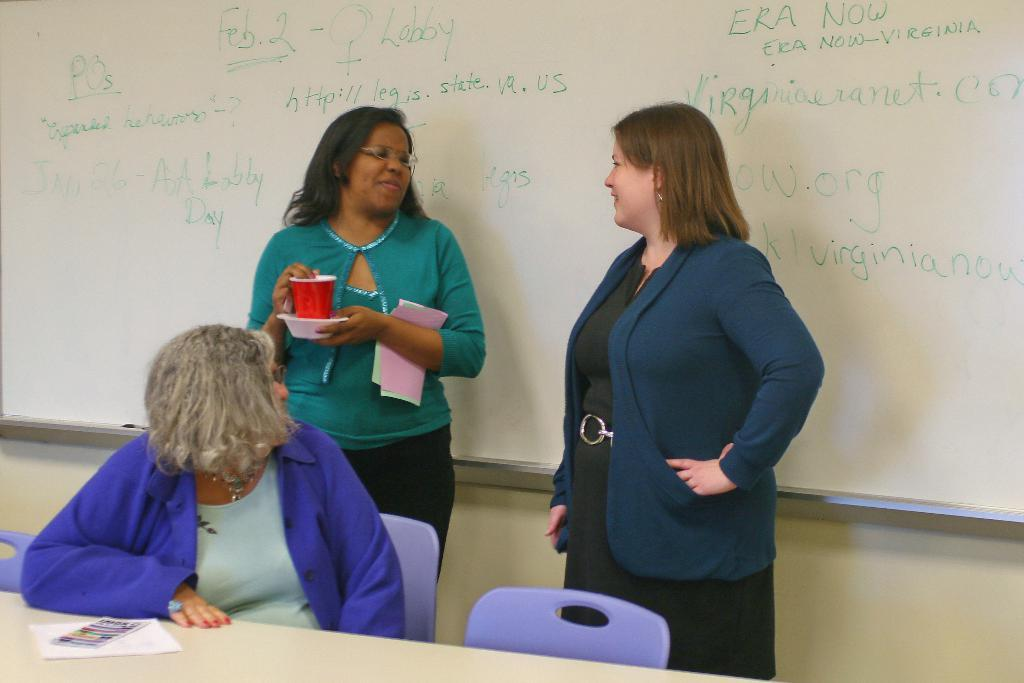Who is present in the foreground of the picture? There are women in the foreground of the picture. What objects can be seen in the foreground of the picture? There is a table, a book, papers, and chairs in the foreground of the picture. What is located in the background of the picture? There is a board in the background of the picture. What type of care can be seen being provided to the monkey in the image? There is no monkey present in the image, so no care can be observed. How many trucks are visible in the image? There are no trucks visible in the image. 